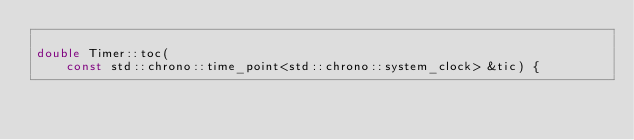<code> <loc_0><loc_0><loc_500><loc_500><_C++_>
double Timer::toc(
    const std::chrono::time_point<std::chrono::system_clock> &tic) {</code> 